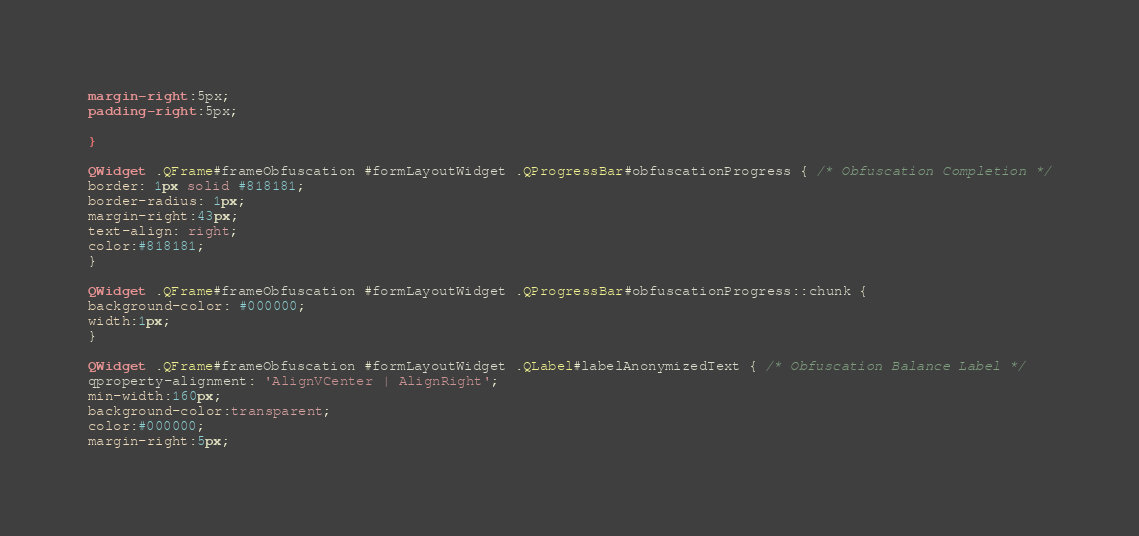<code> <loc_0><loc_0><loc_500><loc_500><_CSS_>margin-right:5px;
padding-right:5px;

}

QWidget .QFrame#frameObfuscation #formLayoutWidget .QProgressBar#obfuscationProgress { /* Obfuscation Completion */
border: 1px solid #818181;
border-radius: 1px;
margin-right:43px;
text-align: right;
color:#818181;
}

QWidget .QFrame#frameObfuscation #formLayoutWidget .QProgressBar#obfuscationProgress::chunk {
background-color: #000000;
width:1px;
}

QWidget .QFrame#frameObfuscation #formLayoutWidget .QLabel#labelAnonymizedText { /* Obfuscation Balance Label */
qproperty-alignment: 'AlignVCenter | AlignRight';
min-width:160px;
background-color:transparent;
color:#000000;
margin-right:5px;</code> 